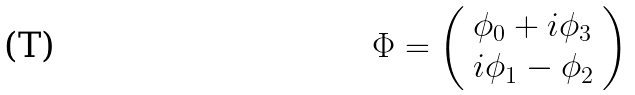<formula> <loc_0><loc_0><loc_500><loc_500>\Phi = \left ( \begin{array} { l } \phi _ { 0 } + i \phi _ { 3 } \\ i \phi _ { 1 } - \phi _ { 2 } \end{array} \right )</formula> 